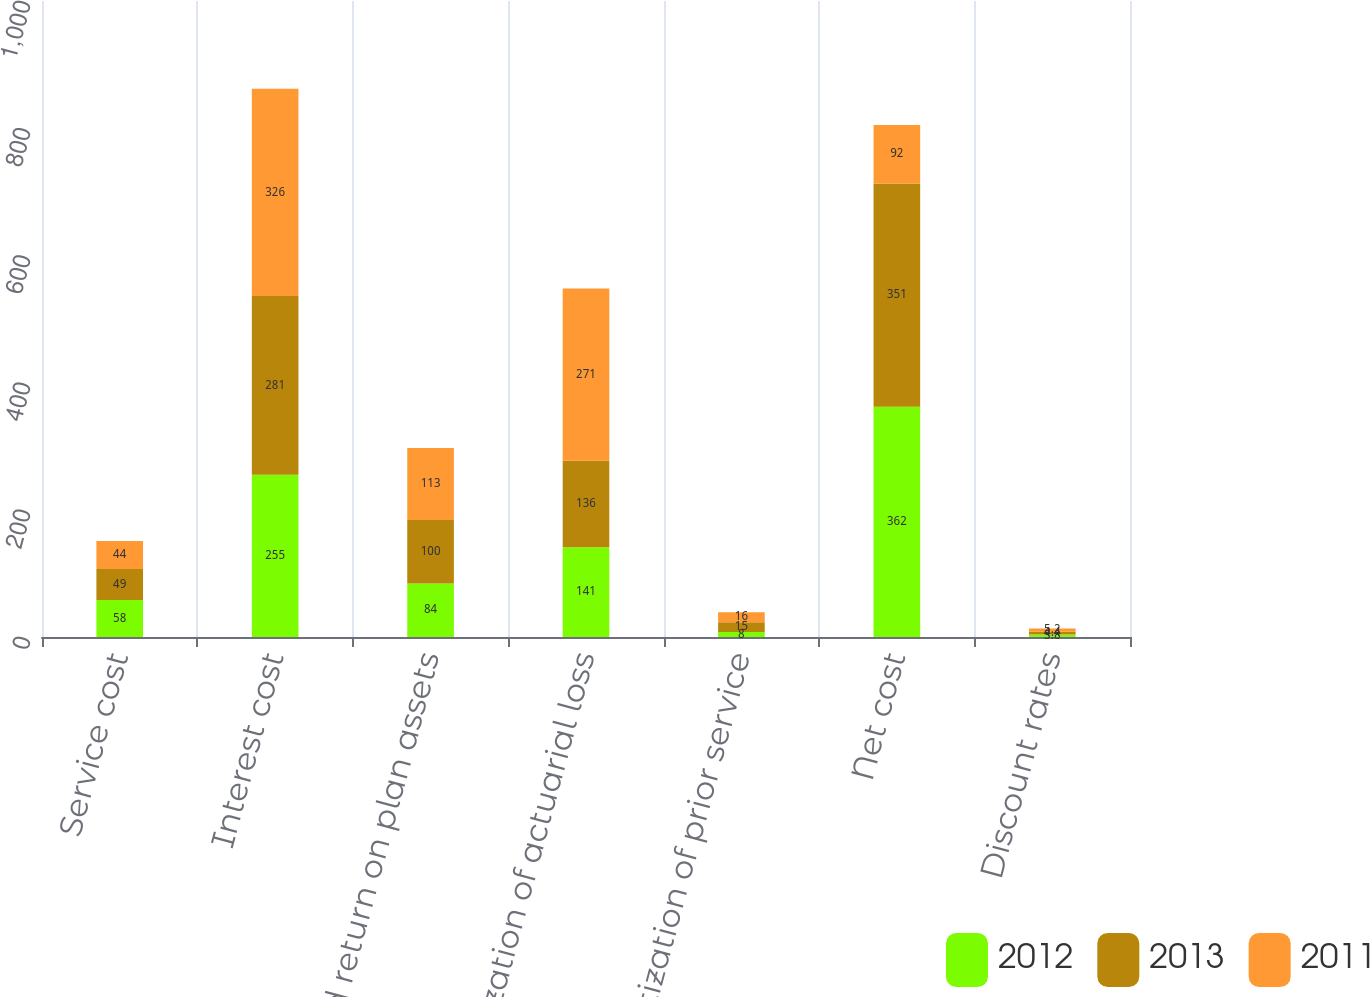Convert chart to OTSL. <chart><loc_0><loc_0><loc_500><loc_500><stacked_bar_chart><ecel><fcel>Service cost<fcel>Interest cost<fcel>Expected return on plan assets<fcel>Amortization of actuarial loss<fcel>Amortization of prior service<fcel>Net cost<fcel>Discount rates<nl><fcel>2012<fcel>58<fcel>255<fcel>84<fcel>141<fcel>8<fcel>362<fcel>3.8<nl><fcel>2013<fcel>49<fcel>281<fcel>100<fcel>136<fcel>15<fcel>351<fcel>4.4<nl><fcel>2011<fcel>44<fcel>326<fcel>113<fcel>271<fcel>16<fcel>92<fcel>5.2<nl></chart> 